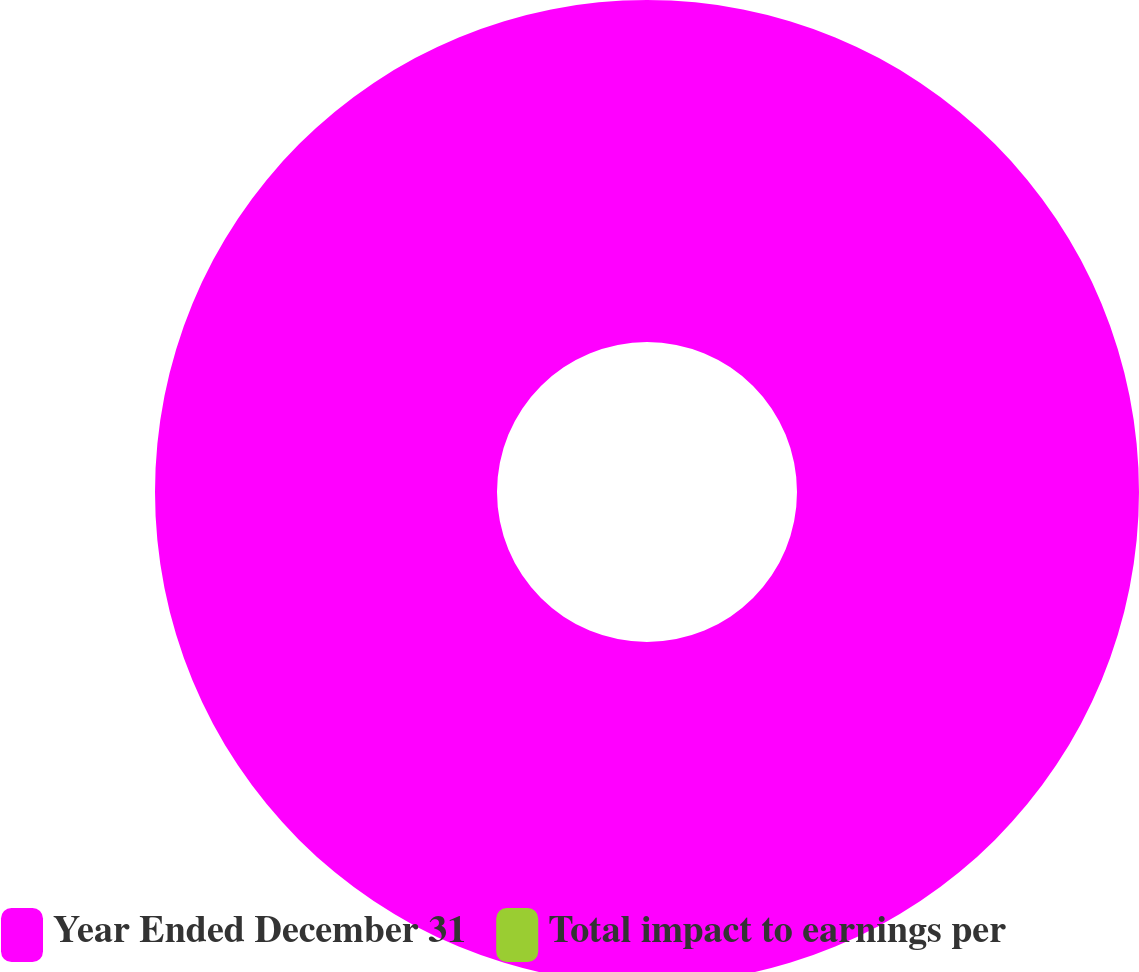Convert chart to OTSL. <chart><loc_0><loc_0><loc_500><loc_500><pie_chart><fcel>Year Ended December 31<fcel>Total impact to earnings per<nl><fcel>100.0%<fcel>0.0%<nl></chart> 